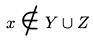<formula> <loc_0><loc_0><loc_500><loc_500>x \notin Y \cup Z</formula> 